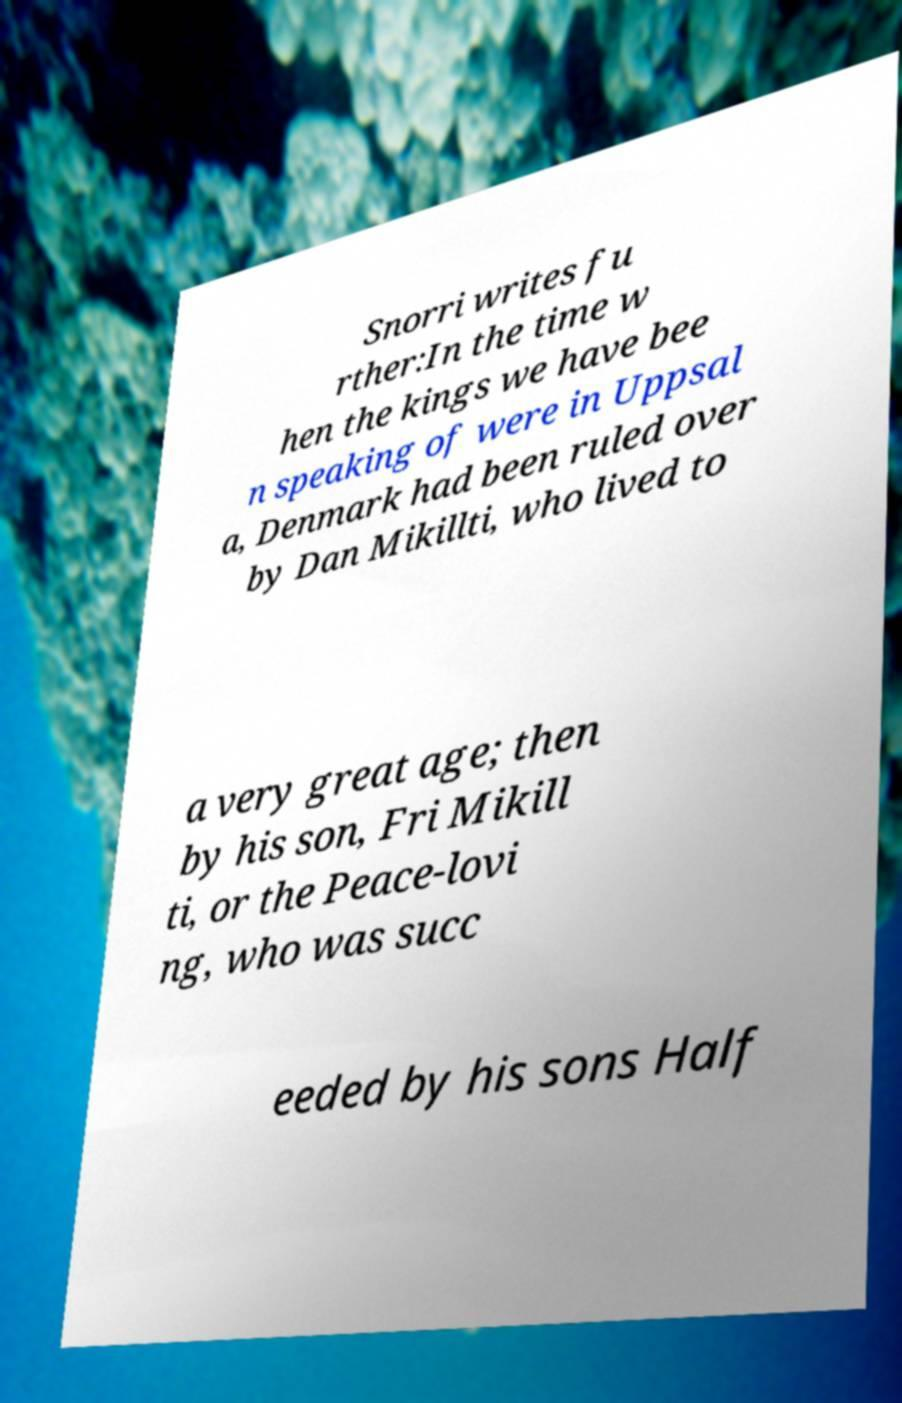Please read and relay the text visible in this image. What does it say? Snorri writes fu rther:In the time w hen the kings we have bee n speaking of were in Uppsal a, Denmark had been ruled over by Dan Mikillti, who lived to a very great age; then by his son, Fri Mikill ti, or the Peace-lovi ng, who was succ eeded by his sons Half 